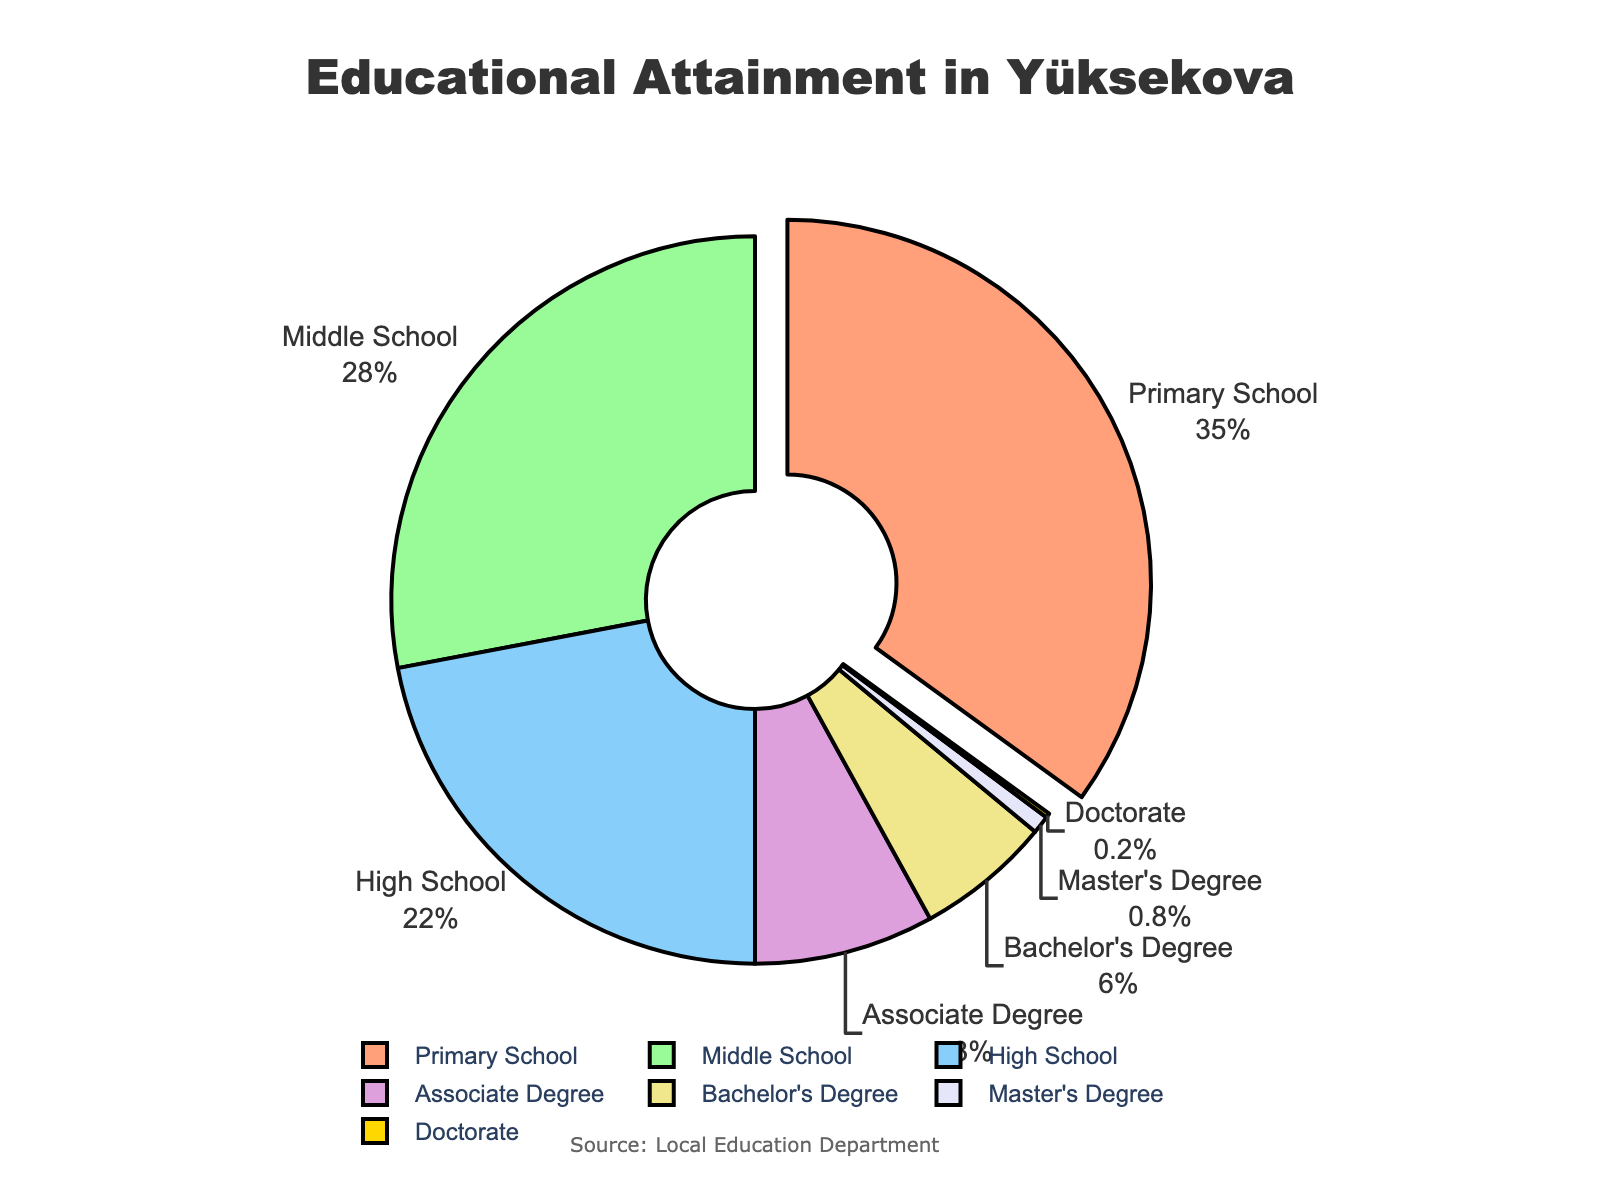What percentage of Yüksekova residents have an educational attainment of high school or higher? To find this percentage, add the percentages of high school (22%), associate degree (8%), bachelor's degree (6%), master's degree (0.8%), and doctorate (0.2%). Then, sum these percentages: 22 + 8 + 6 + 0.8 + 0.2 = 37%.
Answer: 37% Which educational level has the smallest percentage of residents? First, look for the educational level with the smallest percentage. According to the figure, doctorate has the smallest percentage (0.2%).
Answer: Doctorate Is the percentage of middle school graduates higher than that of bachelor's degree holders? Compare the percentage of middle school graduates (28%) with that of bachelor's degree holders (6%). Since 28% is greater than 6%, yes, middle school graduates have a higher percentage.
Answer: Yes How much higher is the percentage of primary school graduates compared to master's degree holders? Subtract the percentage of master's degree holders (0.8%) from that of primary school graduates (35%): 35 - 0.8 = 34.2%.
Answer: 34.2% Sum the percentages of residents with an associate degree and those with a bachelor's degree. Add the two percentages: associate degree (8%) and bachelor's degree (6%). Thus, 8 + 6 = 14%.
Answer: 14% What color represents the high school educational level in the pie chart? Look at the pie slice colors and match the educational level "High School" with its corresponding color, which is visually represented by a specific color. According to the list, high school is represented by a sky blue color (#87CEFA).
Answer: Sky blue Compare the combined percentage of master's and doctorate holders with that of primary school graduates. Which is higher? Add master's (0.8%) and doctorate (0.2%) percentages: 0.8 + 0.2 = 1%. Compare this with the percentage of primary school graduates (35%). The percentage of primary school graduates is higher.
Answer: Primary school graduates What is the total percentage of residents who did not complete high school? Add the percentages of primary school (35%) and middle school (28%) graduates: 35 + 28 = 63%.
Answer: 63% Which educational level is labeled outside the pie chart and has the pull effect applied to it? The pull effect is applied to the slice with the highest percentage. In this case, the primary school (35%) is visually emphasized with the pull effect and labeled outside the chart.
Answer: Primary school 